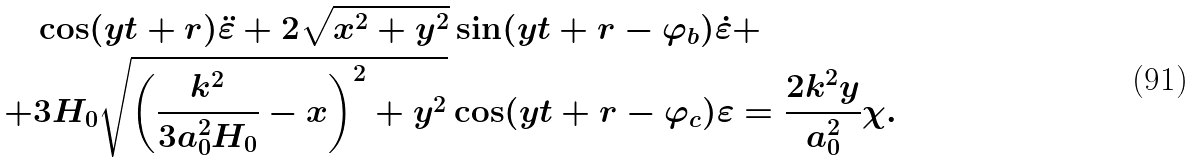Convert formula to latex. <formula><loc_0><loc_0><loc_500><loc_500>& \cos ( y t + r ) \ddot { \varepsilon } + 2 \sqrt { x ^ { 2 } + y ^ { 2 } } \sin ( y t + r - \varphi _ { b } ) \dot { \varepsilon } + \\ + & 3 H _ { 0 } \sqrt { \left ( \frac { k ^ { 2 } } { 3 a _ { 0 } ^ { 2 } H _ { 0 } } - x \right ) ^ { 2 } + y ^ { 2 } } \cos ( y t + r - \varphi _ { c } ) \varepsilon = \frac { 2 k ^ { 2 } y } { a _ { 0 } ^ { 2 } } \chi .</formula> 